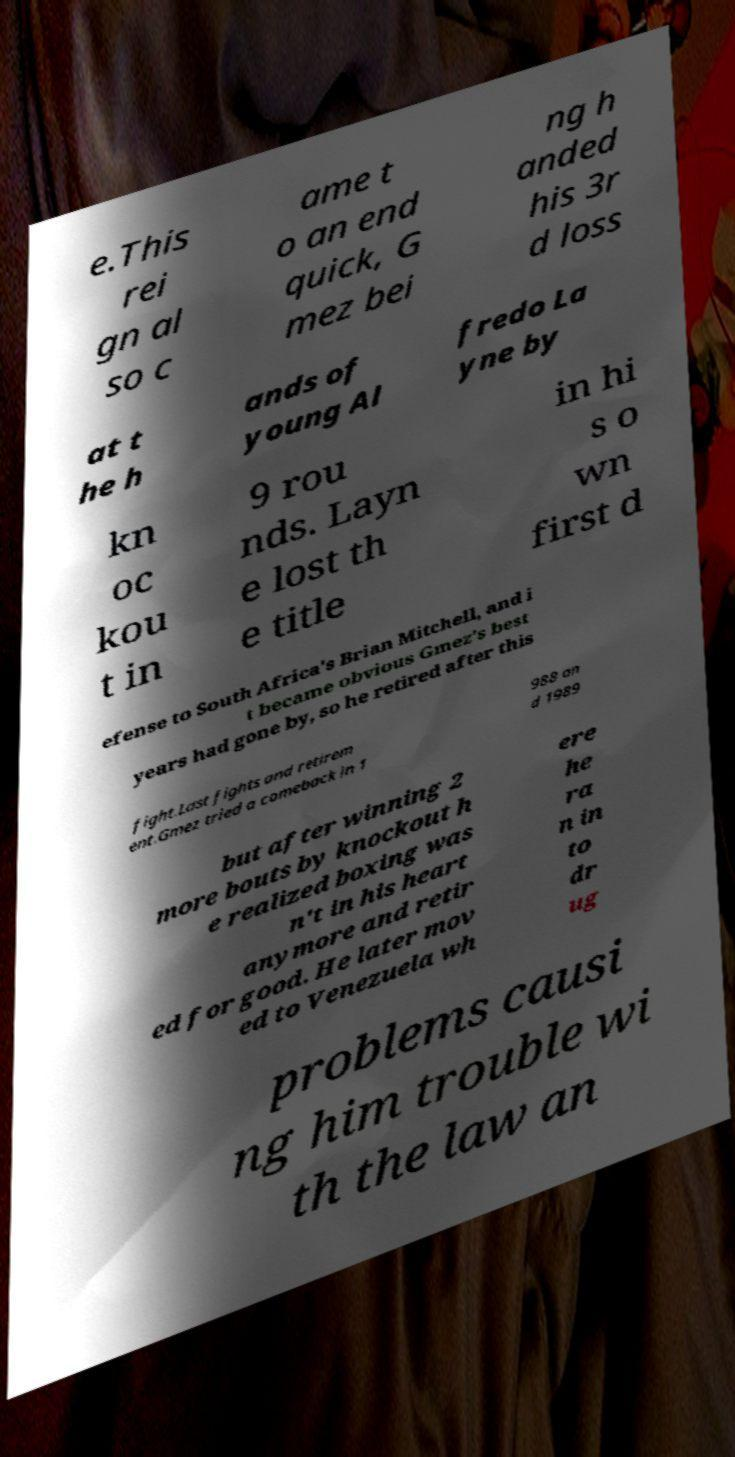Could you assist in decoding the text presented in this image and type it out clearly? e.This rei gn al so c ame t o an end quick, G mez bei ng h anded his 3r d loss at t he h ands of young Al fredo La yne by kn oc kou t in 9 rou nds. Layn e lost th e title in hi s o wn first d efense to South Africa's Brian Mitchell, and i t became obvious Gmez's best years had gone by, so he retired after this fight.Last fights and retirem ent.Gmez tried a comeback in 1 988 an d 1989 but after winning 2 more bouts by knockout h e realized boxing was n't in his heart anymore and retir ed for good. He later mov ed to Venezuela wh ere he ra n in to dr ug problems causi ng him trouble wi th the law an 